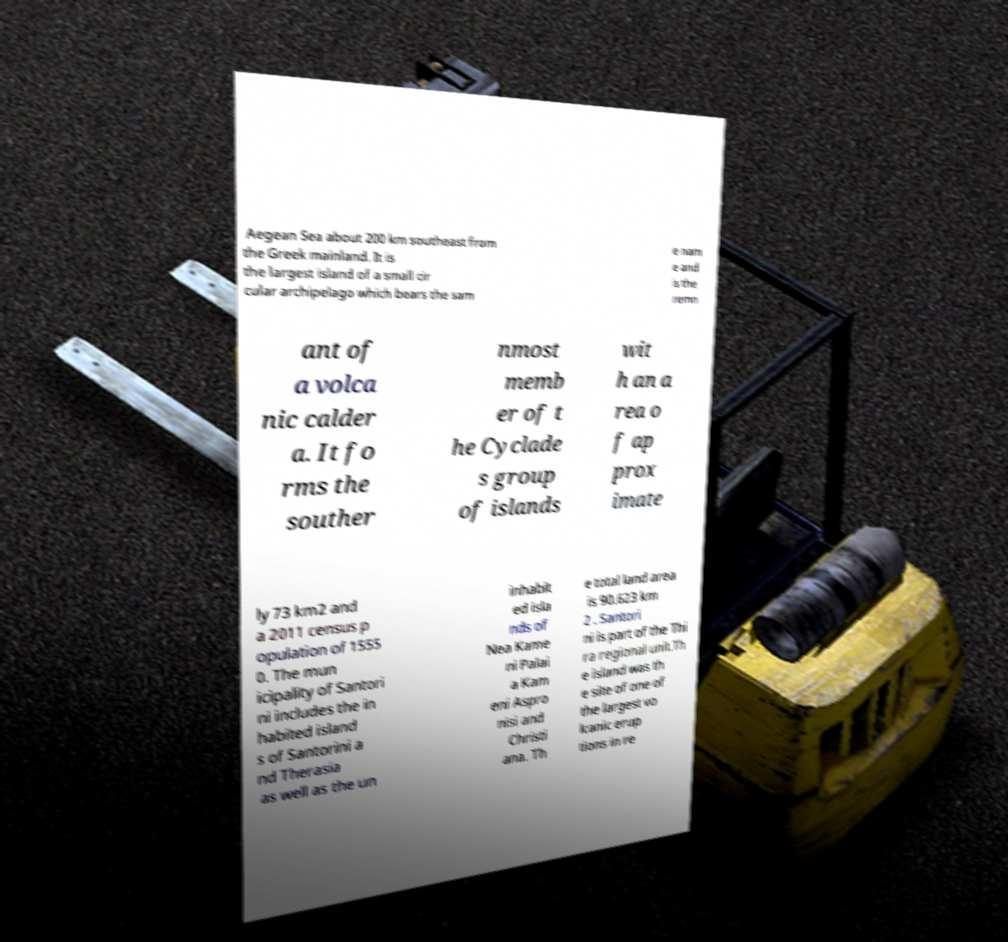Please identify and transcribe the text found in this image. Aegean Sea about 200 km southeast from the Greek mainland. It is the largest island of a small cir cular archipelago which bears the sam e nam e and is the remn ant of a volca nic calder a. It fo rms the souther nmost memb er of t he Cyclade s group of islands wit h an a rea o f ap prox imate ly 73 km2 and a 2011 census p opulation of 1555 0. The mun icipality of Santori ni includes the in habited island s of Santorini a nd Therasia as well as the un inhabit ed isla nds of Nea Kame ni Palai a Kam eni Aspro nisi and Christi ana. Th e total land area is 90.623 km 2 . Santori ni is part of the Thi ra regional unit.Th e island was th e site of one of the largest vo lcanic erup tions in re 